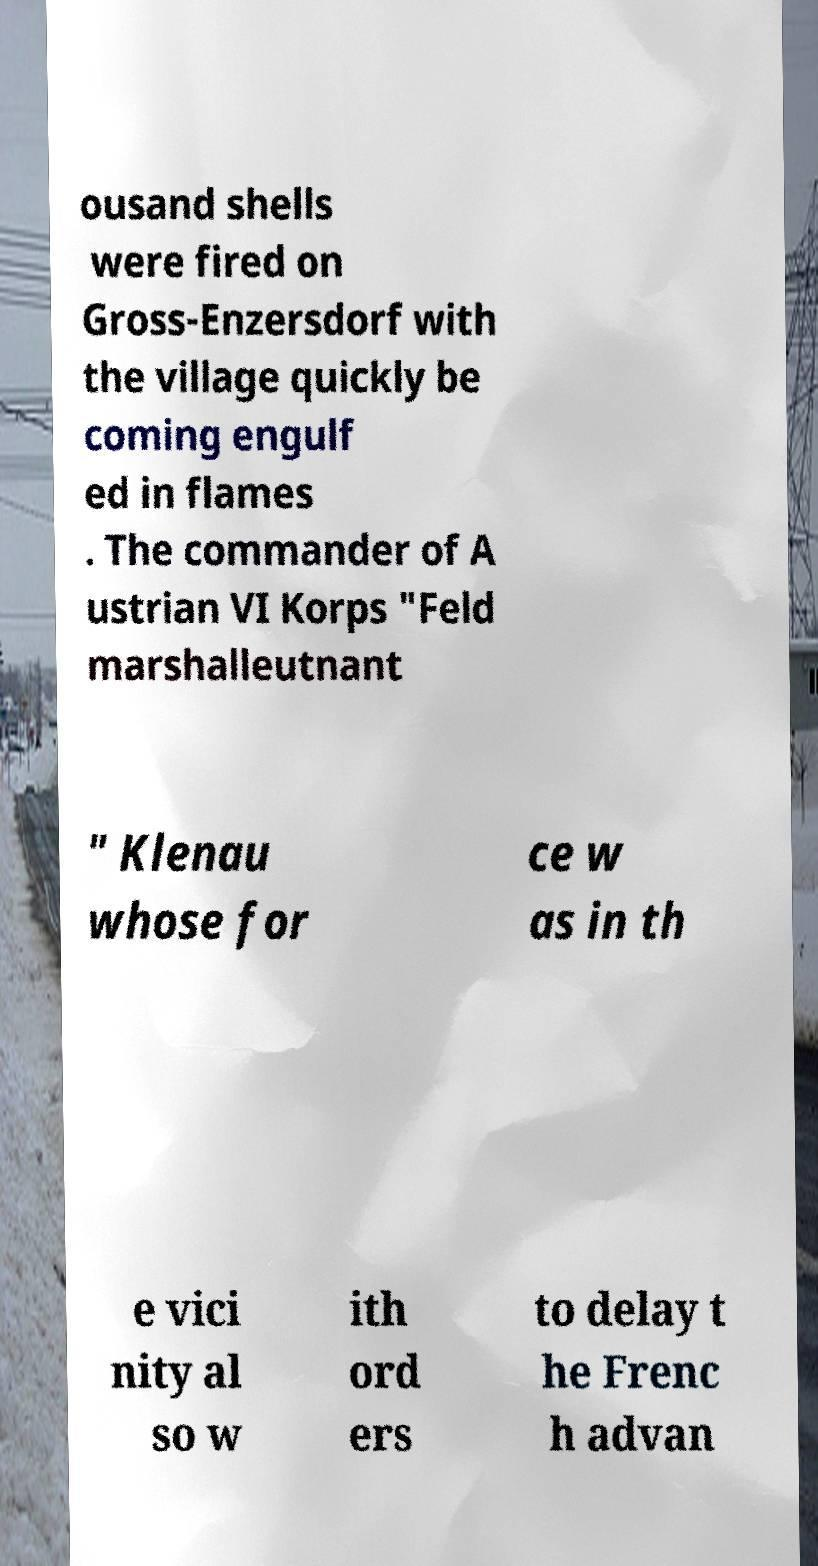Could you assist in decoding the text presented in this image and type it out clearly? ousand shells were fired on Gross-Enzersdorf with the village quickly be coming engulf ed in flames . The commander of A ustrian VI Korps "Feld marshalleutnant " Klenau whose for ce w as in th e vici nity al so w ith ord ers to delay t he Frenc h advan 